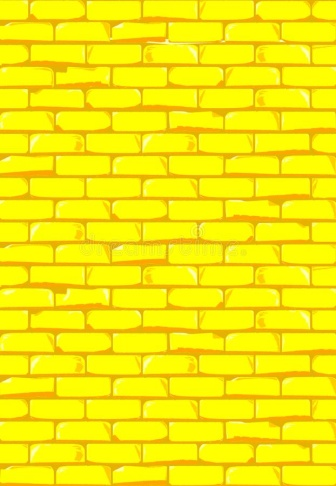How might the condition and quality of this yellow brick wall influence one's perception of the building it is part of? The pristine condition and quality of the brickwork suggest high maintenance and could reflect the owner's commitment to preservation. This can inspire confidence and respect in the viewer, possibly elevating the perceived value and prestige of the building. It might indicate that the building is well-cared for, inferring that other aspects of the structure are equally well-maintained. 